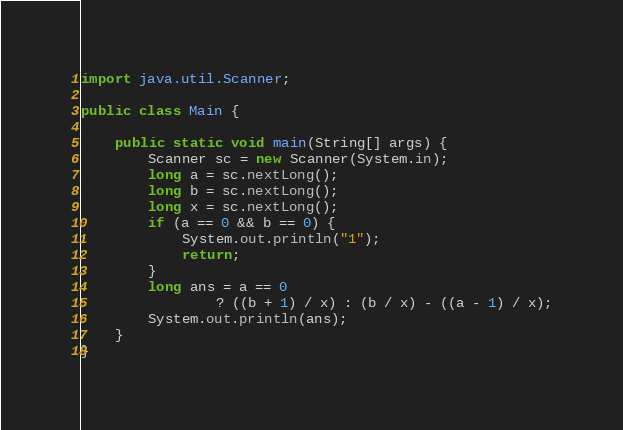Convert code to text. <code><loc_0><loc_0><loc_500><loc_500><_Java_>import java.util.Scanner;

public class Main {

    public static void main(String[] args) {
        Scanner sc = new Scanner(System.in);
        long a = sc.nextLong();
        long b = sc.nextLong();
        long x = sc.nextLong();
        if (a == 0 && b == 0) {
            System.out.println("1");
            return;
        }
        long ans = a == 0
                ? ((b + 1) / x) : (b / x) - ((a - 1) / x);
        System.out.println(ans);
    }
}</code> 